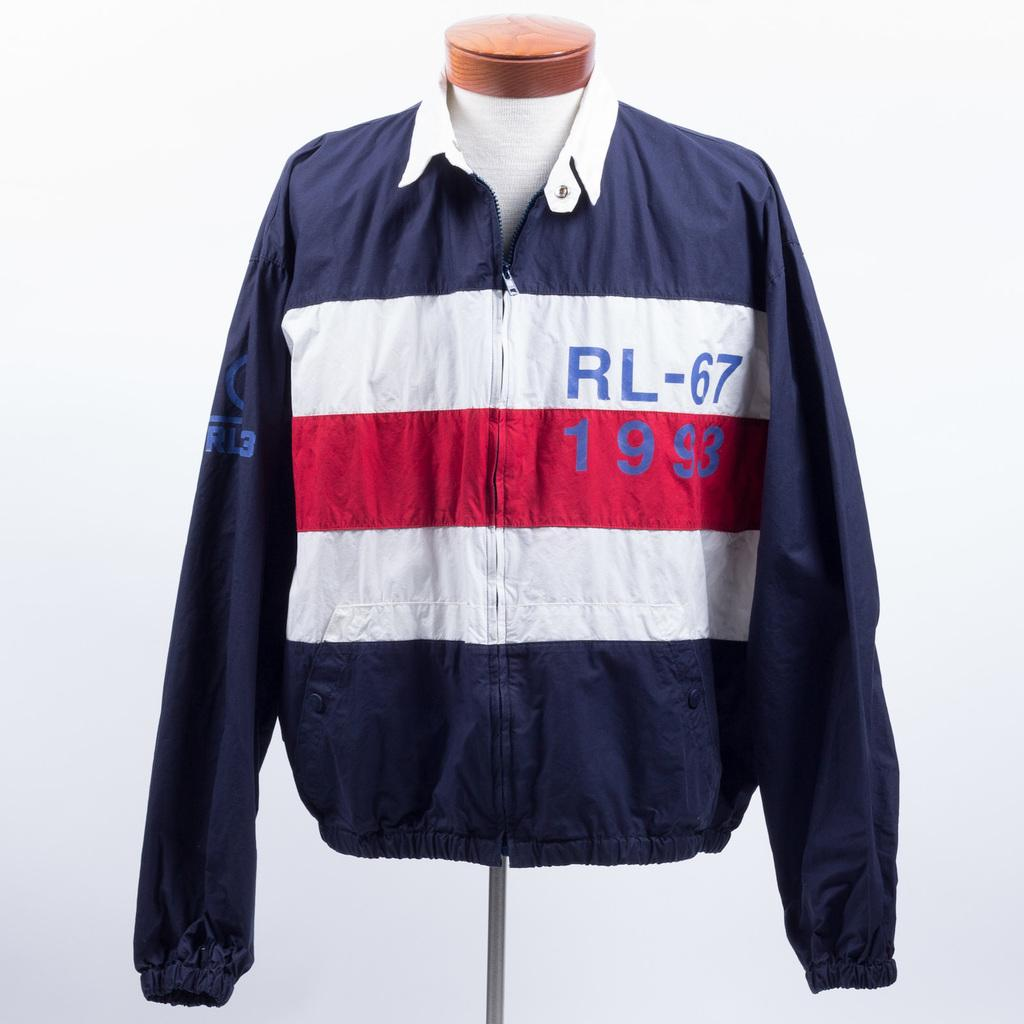<image>
Give a short and clear explanation of the subsequent image. The jacket displays the year 1993 along with other numbers. 